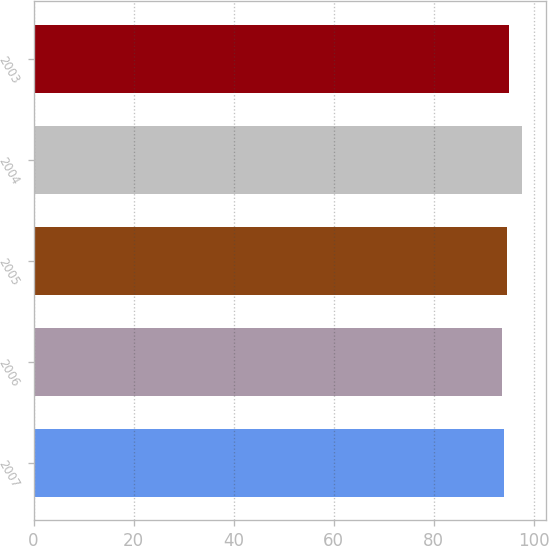Convert chart to OTSL. <chart><loc_0><loc_0><loc_500><loc_500><bar_chart><fcel>2007<fcel>2006<fcel>2005<fcel>2004<fcel>2003<nl><fcel>94<fcel>93.6<fcel>94.7<fcel>97.6<fcel>95.1<nl></chart> 